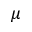Convert formula to latex. <formula><loc_0><loc_0><loc_500><loc_500>\mu</formula> 